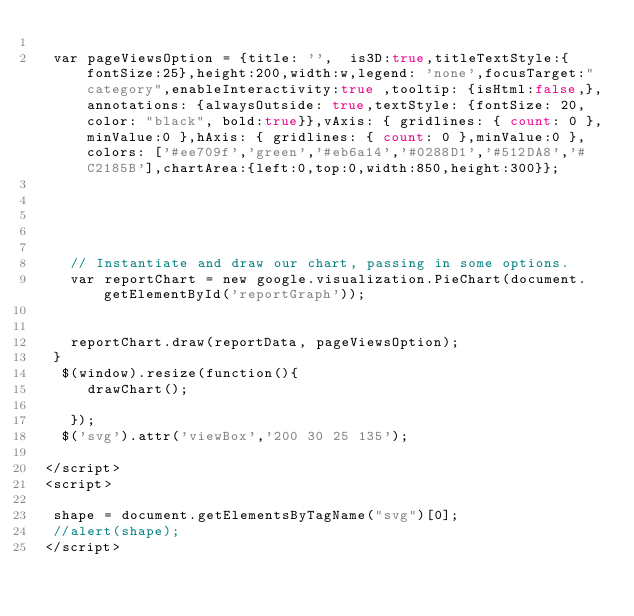Convert code to text. <code><loc_0><loc_0><loc_500><loc_500><_PHP_>  
  var pageViewsOption = {title: '',  is3D:true,titleTextStyle:{fontSize:25},height:200,width:w,legend: 'none',focusTarget:"category",enableInteractivity:true ,tooltip: {isHtml:false,},annotations: {alwaysOutside: true,textStyle: {fontSize: 20,color: "black", bold:true}},vAxis: { gridlines: { count: 0 },minValue:0 },hAxis: { gridlines: { count: 0 },minValue:0 },colors: ['#ee709f','green','#eb6a14','#0288D1','#512DA8','#C2185B'],chartArea:{left:0,top:0,width:850,height:300}};
  
 
 

 
    // Instantiate and draw our chart, passing in some options.
    var reportChart = new google.visualization.PieChart(document.getElementById('reportGraph'));
    
    
    reportChart.draw(reportData, pageViewsOption);  
  }
   $(window).resize(function(){
      drawChart();

    });
   $('svg').attr('viewBox','200 30 25 135');

 </script>
 <script>
  
  shape = document.getElementsByTagName("svg")[0];
  //alert(shape);
 </script></code> 